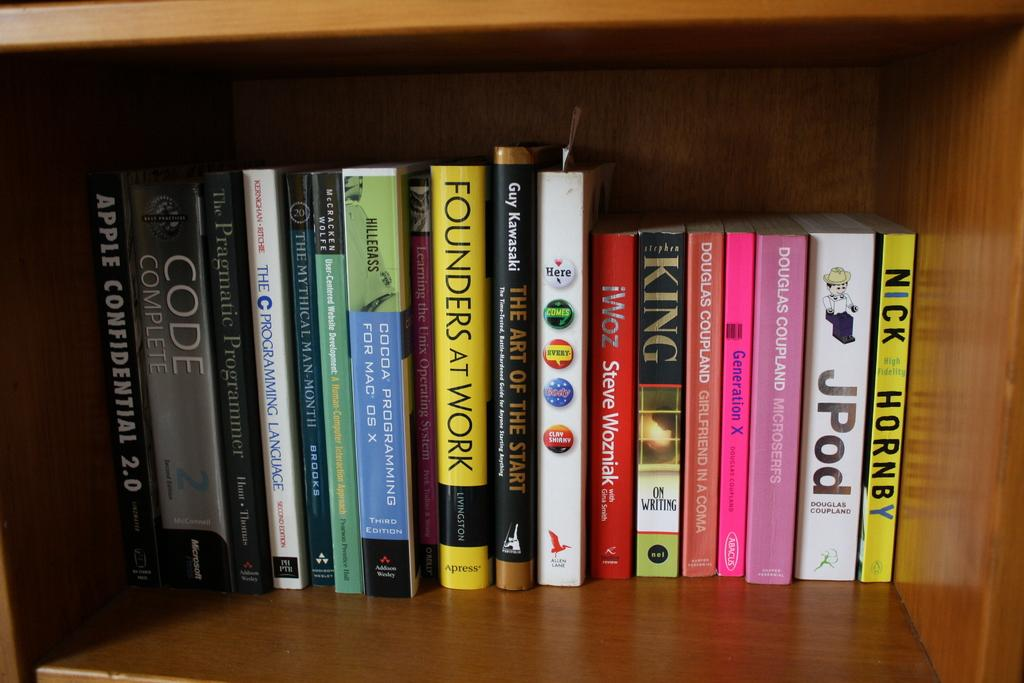<image>
Relay a brief, clear account of the picture shown. Many books are on a shelf, including Nick Hornby's High Fidelity. 